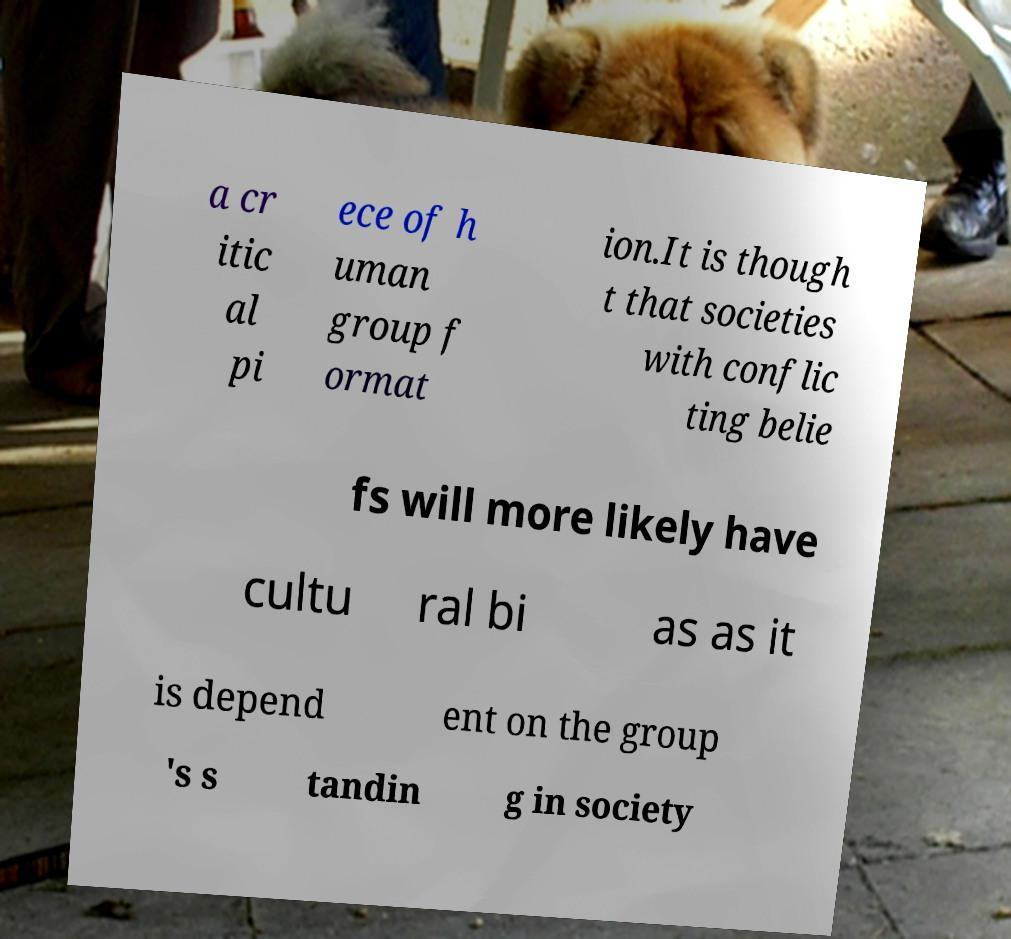I need the written content from this picture converted into text. Can you do that? a cr itic al pi ece of h uman group f ormat ion.It is though t that societies with conflic ting belie fs will more likely have cultu ral bi as as it is depend ent on the group 's s tandin g in society 